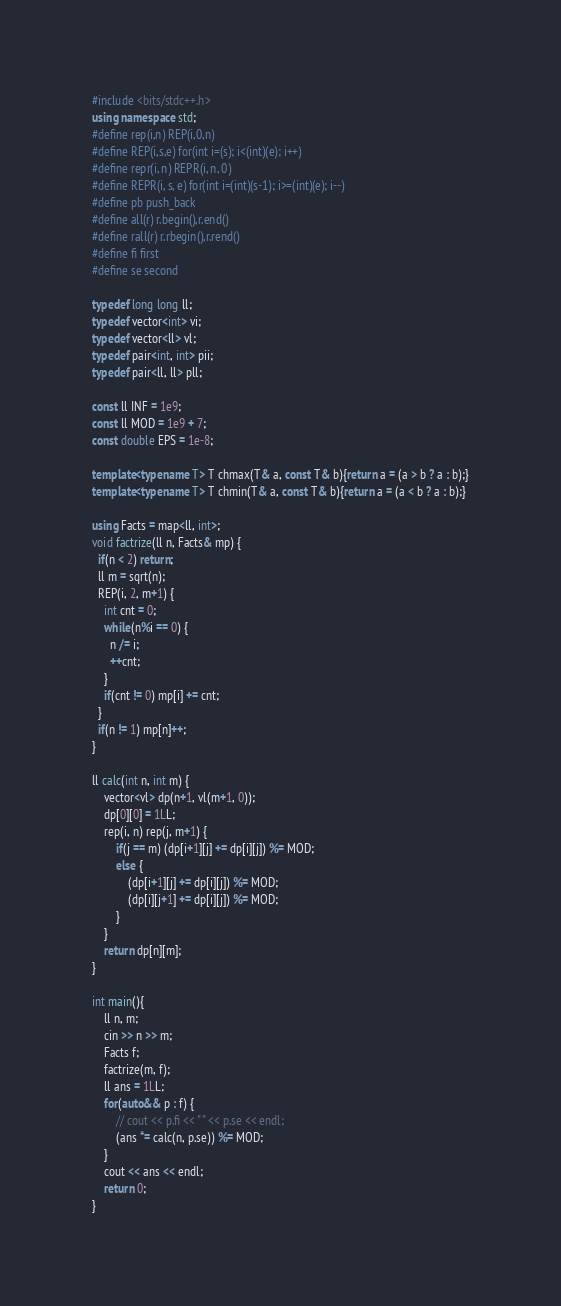<code> <loc_0><loc_0><loc_500><loc_500><_C++_>#include <bits/stdc++.h>
using namespace std;
#define rep(i,n) REP(i,0,n)
#define REP(i,s,e) for(int i=(s); i<(int)(e); i++)
#define repr(i, n) REPR(i, n, 0)
#define REPR(i, s, e) for(int i=(int)(s-1); i>=(int)(e); i--)
#define pb push_back
#define all(r) r.begin(),r.end()
#define rall(r) r.rbegin(),r.rend()
#define fi first
#define se second

typedef long long ll;
typedef vector<int> vi;
typedef vector<ll> vl;
typedef pair<int, int> pii;
typedef pair<ll, ll> pll;

const ll INF = 1e9;
const ll MOD = 1e9 + 7;
const double EPS = 1e-8;

template<typename T> T chmax(T& a, const T& b){return a = (a > b ? a : b);}
template<typename T> T chmin(T& a, const T& b){return a = (a < b ? a : b);}

using Facts = map<ll, int>; 
void factrize(ll n, Facts& mp) {
  if(n < 2) return;
  ll m = sqrt(n);
  REP(i, 2, m+1) {
    int cnt = 0;
    while(n%i == 0) {
      n /= i;
      ++cnt;
    }
    if(cnt != 0) mp[i] += cnt;
  }
  if(n != 1) mp[n]++;
}

ll calc(int n, int m) {
    vector<vl> dp(n+1, vl(m+1, 0));
    dp[0][0] = 1LL;
    rep(i, n) rep(j, m+1) {
        if(j == m) (dp[i+1][j] += dp[i][j]) %= MOD;
        else {
            (dp[i+1][j] += dp[i][j]) %= MOD;
            (dp[i][j+1] += dp[i][j]) %= MOD;
        }
    }
    return dp[n][m];
}

int main(){
    ll n, m;
    cin >> n >> m;
    Facts f;
    factrize(m, f);
    ll ans = 1LL;
    for(auto&& p : f) {
        // cout << p.fi << " " << p.se << endl;
        (ans *= calc(n, p.se)) %= MOD;
    }
    cout << ans << endl;
    return 0;
}</code> 